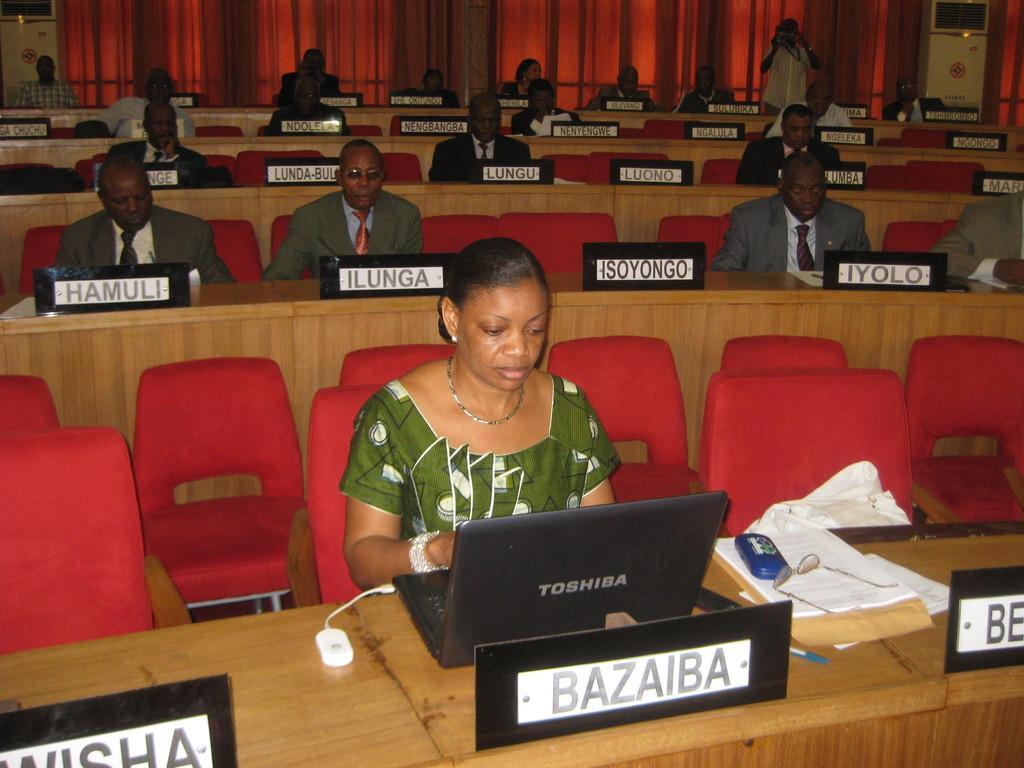In one or two sentences, can you explain what this image depicts? There are group of people sitting on the chairs which are red in color. Here is a woman sitting on the chair and using laptop. This is a table with a name board,papers,spectacles,pen and some white object placed on it. At background I can see a red colored cloth hanging through the hangers. This is a man standing. At the top right corner of the image I can see a white color object,I think it is an air conditioner. 